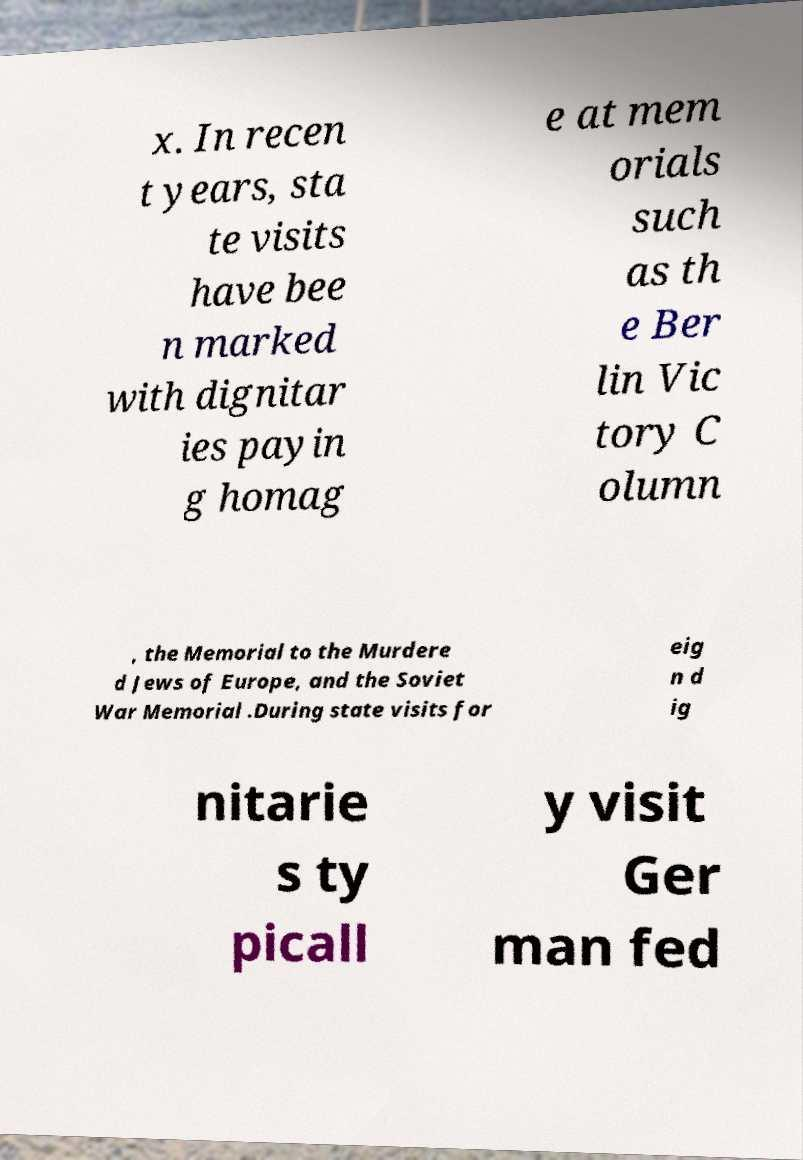Please read and relay the text visible in this image. What does it say? x. In recen t years, sta te visits have bee n marked with dignitar ies payin g homag e at mem orials such as th e Ber lin Vic tory C olumn , the Memorial to the Murdere d Jews of Europe, and the Soviet War Memorial .During state visits for eig n d ig nitarie s ty picall y visit Ger man fed 